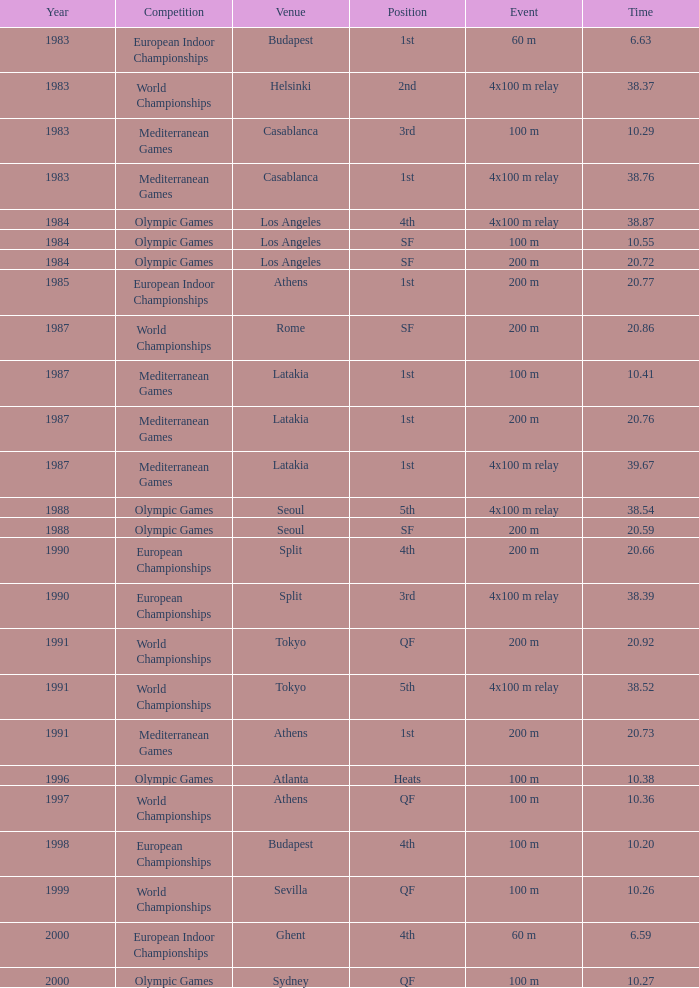What placement has a duration of 2 4th. 